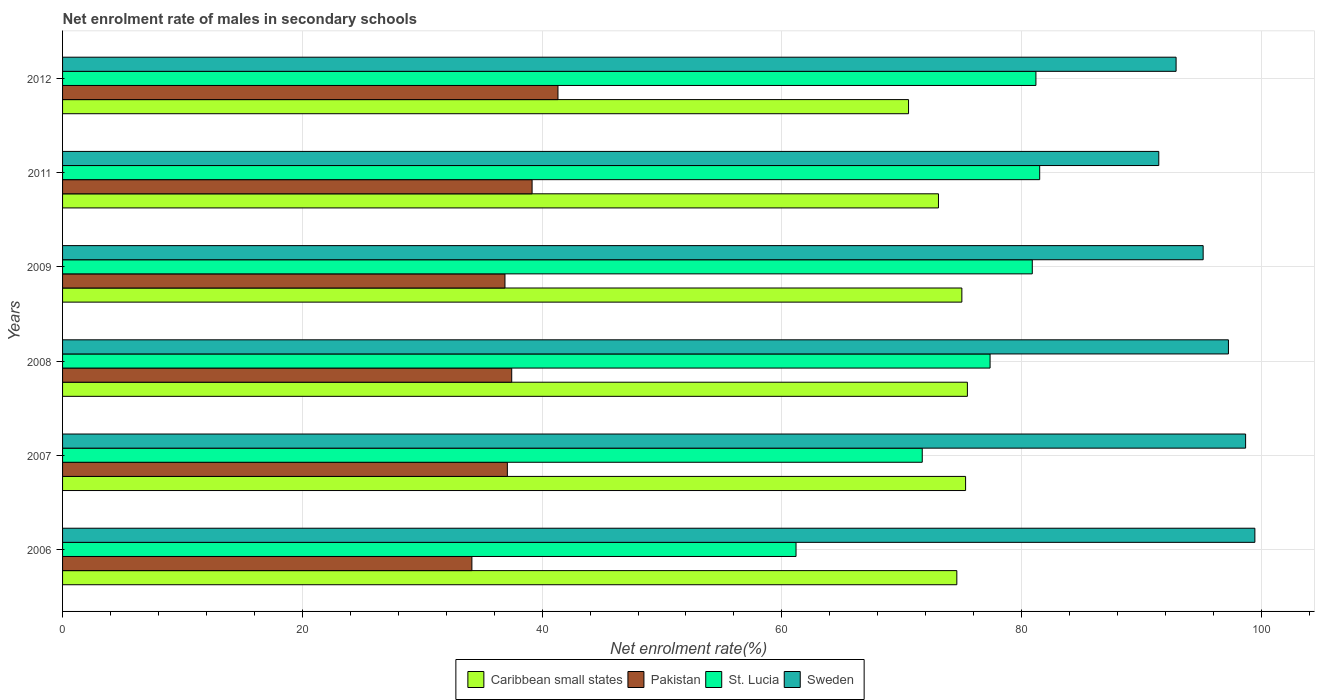How many groups of bars are there?
Keep it short and to the point. 6. How many bars are there on the 5th tick from the bottom?
Your answer should be compact. 4. What is the net enrolment rate of males in secondary schools in Sweden in 2007?
Your answer should be very brief. 98.68. Across all years, what is the maximum net enrolment rate of males in secondary schools in Caribbean small states?
Make the answer very short. 75.48. Across all years, what is the minimum net enrolment rate of males in secondary schools in Sweden?
Offer a terse response. 91.44. In which year was the net enrolment rate of males in secondary schools in Sweden maximum?
Provide a succinct answer. 2006. In which year was the net enrolment rate of males in secondary schools in Sweden minimum?
Offer a very short reply. 2011. What is the total net enrolment rate of males in secondary schools in Sweden in the graph?
Your answer should be very brief. 574.85. What is the difference between the net enrolment rate of males in secondary schools in Caribbean small states in 2008 and that in 2012?
Offer a terse response. 4.91. What is the difference between the net enrolment rate of males in secondary schools in Sweden in 2009 and the net enrolment rate of males in secondary schools in St. Lucia in 2011?
Offer a terse response. 13.63. What is the average net enrolment rate of males in secondary schools in Sweden per year?
Give a very brief answer. 95.81. In the year 2006, what is the difference between the net enrolment rate of males in secondary schools in St. Lucia and net enrolment rate of males in secondary schools in Sweden?
Offer a very short reply. -38.27. In how many years, is the net enrolment rate of males in secondary schools in Sweden greater than 24 %?
Make the answer very short. 6. What is the ratio of the net enrolment rate of males in secondary schools in St. Lucia in 2007 to that in 2008?
Your answer should be very brief. 0.93. Is the net enrolment rate of males in secondary schools in Pakistan in 2009 less than that in 2012?
Provide a short and direct response. Yes. What is the difference between the highest and the second highest net enrolment rate of males in secondary schools in Sweden?
Provide a succinct answer. 0.77. What is the difference between the highest and the lowest net enrolment rate of males in secondary schools in Caribbean small states?
Make the answer very short. 4.91. Is it the case that in every year, the sum of the net enrolment rate of males in secondary schools in Sweden and net enrolment rate of males in secondary schools in Caribbean small states is greater than the sum of net enrolment rate of males in secondary schools in Pakistan and net enrolment rate of males in secondary schools in St. Lucia?
Offer a very short reply. No. What does the 1st bar from the top in 2006 represents?
Your answer should be compact. Sweden. What does the 1st bar from the bottom in 2011 represents?
Keep it short and to the point. Caribbean small states. How many bars are there?
Provide a short and direct response. 24. What is the difference between two consecutive major ticks on the X-axis?
Keep it short and to the point. 20. Does the graph contain grids?
Ensure brevity in your answer.  Yes. Where does the legend appear in the graph?
Provide a short and direct response. Bottom center. How are the legend labels stacked?
Offer a terse response. Horizontal. What is the title of the graph?
Provide a short and direct response. Net enrolment rate of males in secondary schools. What is the label or title of the X-axis?
Make the answer very short. Net enrolment rate(%). What is the Net enrolment rate(%) in Caribbean small states in 2006?
Keep it short and to the point. 74.59. What is the Net enrolment rate(%) in Pakistan in 2006?
Offer a very short reply. 34.14. What is the Net enrolment rate(%) of St. Lucia in 2006?
Provide a succinct answer. 61.18. What is the Net enrolment rate(%) in Sweden in 2006?
Your answer should be compact. 99.46. What is the Net enrolment rate(%) in Caribbean small states in 2007?
Offer a very short reply. 75.32. What is the Net enrolment rate(%) of Pakistan in 2007?
Make the answer very short. 37.1. What is the Net enrolment rate(%) in St. Lucia in 2007?
Make the answer very short. 71.71. What is the Net enrolment rate(%) in Sweden in 2007?
Keep it short and to the point. 98.68. What is the Net enrolment rate(%) of Caribbean small states in 2008?
Make the answer very short. 75.48. What is the Net enrolment rate(%) in Pakistan in 2008?
Your response must be concise. 37.47. What is the Net enrolment rate(%) of St. Lucia in 2008?
Keep it short and to the point. 77.37. What is the Net enrolment rate(%) in Sweden in 2008?
Ensure brevity in your answer.  97.25. What is the Net enrolment rate(%) of Caribbean small states in 2009?
Your response must be concise. 75.01. What is the Net enrolment rate(%) in Pakistan in 2009?
Ensure brevity in your answer.  36.9. What is the Net enrolment rate(%) in St. Lucia in 2009?
Your response must be concise. 80.89. What is the Net enrolment rate(%) in Sweden in 2009?
Offer a terse response. 95.14. What is the Net enrolment rate(%) of Caribbean small states in 2011?
Your answer should be very brief. 73.06. What is the Net enrolment rate(%) of Pakistan in 2011?
Keep it short and to the point. 39.17. What is the Net enrolment rate(%) of St. Lucia in 2011?
Offer a terse response. 81.51. What is the Net enrolment rate(%) in Sweden in 2011?
Offer a terse response. 91.44. What is the Net enrolment rate(%) of Caribbean small states in 2012?
Your answer should be very brief. 70.57. What is the Net enrolment rate(%) of Pakistan in 2012?
Provide a short and direct response. 41.32. What is the Net enrolment rate(%) in St. Lucia in 2012?
Your response must be concise. 81.19. What is the Net enrolment rate(%) in Sweden in 2012?
Offer a very short reply. 92.88. Across all years, what is the maximum Net enrolment rate(%) of Caribbean small states?
Give a very brief answer. 75.48. Across all years, what is the maximum Net enrolment rate(%) in Pakistan?
Your answer should be compact. 41.32. Across all years, what is the maximum Net enrolment rate(%) of St. Lucia?
Your answer should be very brief. 81.51. Across all years, what is the maximum Net enrolment rate(%) in Sweden?
Offer a terse response. 99.46. Across all years, what is the minimum Net enrolment rate(%) of Caribbean small states?
Make the answer very short. 70.57. Across all years, what is the minimum Net enrolment rate(%) of Pakistan?
Your answer should be compact. 34.14. Across all years, what is the minimum Net enrolment rate(%) of St. Lucia?
Provide a short and direct response. 61.18. Across all years, what is the minimum Net enrolment rate(%) of Sweden?
Keep it short and to the point. 91.44. What is the total Net enrolment rate(%) of Caribbean small states in the graph?
Make the answer very short. 444.04. What is the total Net enrolment rate(%) in Pakistan in the graph?
Your response must be concise. 226.1. What is the total Net enrolment rate(%) in St. Lucia in the graph?
Provide a short and direct response. 453.84. What is the total Net enrolment rate(%) of Sweden in the graph?
Keep it short and to the point. 574.85. What is the difference between the Net enrolment rate(%) in Caribbean small states in 2006 and that in 2007?
Offer a very short reply. -0.73. What is the difference between the Net enrolment rate(%) in Pakistan in 2006 and that in 2007?
Your response must be concise. -2.96. What is the difference between the Net enrolment rate(%) in St. Lucia in 2006 and that in 2007?
Make the answer very short. -10.53. What is the difference between the Net enrolment rate(%) of Sweden in 2006 and that in 2007?
Offer a very short reply. 0.77. What is the difference between the Net enrolment rate(%) of Caribbean small states in 2006 and that in 2008?
Provide a short and direct response. -0.88. What is the difference between the Net enrolment rate(%) in Pakistan in 2006 and that in 2008?
Your answer should be very brief. -3.32. What is the difference between the Net enrolment rate(%) of St. Lucia in 2006 and that in 2008?
Offer a very short reply. -16.19. What is the difference between the Net enrolment rate(%) of Sweden in 2006 and that in 2008?
Offer a very short reply. 2.21. What is the difference between the Net enrolment rate(%) of Caribbean small states in 2006 and that in 2009?
Keep it short and to the point. -0.42. What is the difference between the Net enrolment rate(%) in Pakistan in 2006 and that in 2009?
Offer a very short reply. -2.76. What is the difference between the Net enrolment rate(%) in St. Lucia in 2006 and that in 2009?
Make the answer very short. -19.71. What is the difference between the Net enrolment rate(%) in Sweden in 2006 and that in 2009?
Keep it short and to the point. 4.31. What is the difference between the Net enrolment rate(%) in Caribbean small states in 2006 and that in 2011?
Provide a short and direct response. 1.53. What is the difference between the Net enrolment rate(%) in Pakistan in 2006 and that in 2011?
Your answer should be very brief. -5.02. What is the difference between the Net enrolment rate(%) of St. Lucia in 2006 and that in 2011?
Offer a terse response. -20.32. What is the difference between the Net enrolment rate(%) in Sweden in 2006 and that in 2011?
Keep it short and to the point. 8.02. What is the difference between the Net enrolment rate(%) in Caribbean small states in 2006 and that in 2012?
Make the answer very short. 4.03. What is the difference between the Net enrolment rate(%) in Pakistan in 2006 and that in 2012?
Make the answer very short. -7.18. What is the difference between the Net enrolment rate(%) in St. Lucia in 2006 and that in 2012?
Keep it short and to the point. -20.01. What is the difference between the Net enrolment rate(%) in Sweden in 2006 and that in 2012?
Ensure brevity in your answer.  6.57. What is the difference between the Net enrolment rate(%) of Caribbean small states in 2007 and that in 2008?
Ensure brevity in your answer.  -0.15. What is the difference between the Net enrolment rate(%) of Pakistan in 2007 and that in 2008?
Offer a very short reply. -0.36. What is the difference between the Net enrolment rate(%) of St. Lucia in 2007 and that in 2008?
Provide a short and direct response. -5.66. What is the difference between the Net enrolment rate(%) in Sweden in 2007 and that in 2008?
Ensure brevity in your answer.  1.43. What is the difference between the Net enrolment rate(%) of Caribbean small states in 2007 and that in 2009?
Offer a terse response. 0.31. What is the difference between the Net enrolment rate(%) of Pakistan in 2007 and that in 2009?
Give a very brief answer. 0.2. What is the difference between the Net enrolment rate(%) of St. Lucia in 2007 and that in 2009?
Ensure brevity in your answer.  -9.18. What is the difference between the Net enrolment rate(%) in Sweden in 2007 and that in 2009?
Provide a succinct answer. 3.54. What is the difference between the Net enrolment rate(%) in Caribbean small states in 2007 and that in 2011?
Your response must be concise. 2.26. What is the difference between the Net enrolment rate(%) of Pakistan in 2007 and that in 2011?
Provide a succinct answer. -2.06. What is the difference between the Net enrolment rate(%) in St. Lucia in 2007 and that in 2011?
Make the answer very short. -9.8. What is the difference between the Net enrolment rate(%) in Sweden in 2007 and that in 2011?
Offer a terse response. 7.24. What is the difference between the Net enrolment rate(%) of Caribbean small states in 2007 and that in 2012?
Make the answer very short. 4.76. What is the difference between the Net enrolment rate(%) in Pakistan in 2007 and that in 2012?
Your answer should be very brief. -4.22. What is the difference between the Net enrolment rate(%) of St. Lucia in 2007 and that in 2012?
Your answer should be very brief. -9.48. What is the difference between the Net enrolment rate(%) of Sweden in 2007 and that in 2012?
Offer a very short reply. 5.8. What is the difference between the Net enrolment rate(%) of Caribbean small states in 2008 and that in 2009?
Give a very brief answer. 0.46. What is the difference between the Net enrolment rate(%) of Pakistan in 2008 and that in 2009?
Your answer should be very brief. 0.56. What is the difference between the Net enrolment rate(%) in St. Lucia in 2008 and that in 2009?
Give a very brief answer. -3.52. What is the difference between the Net enrolment rate(%) of Sweden in 2008 and that in 2009?
Ensure brevity in your answer.  2.11. What is the difference between the Net enrolment rate(%) of Caribbean small states in 2008 and that in 2011?
Provide a short and direct response. 2.41. What is the difference between the Net enrolment rate(%) in Pakistan in 2008 and that in 2011?
Your answer should be compact. -1.7. What is the difference between the Net enrolment rate(%) of St. Lucia in 2008 and that in 2011?
Give a very brief answer. -4.14. What is the difference between the Net enrolment rate(%) in Sweden in 2008 and that in 2011?
Give a very brief answer. 5.81. What is the difference between the Net enrolment rate(%) of Caribbean small states in 2008 and that in 2012?
Your answer should be very brief. 4.91. What is the difference between the Net enrolment rate(%) in Pakistan in 2008 and that in 2012?
Your response must be concise. -3.86. What is the difference between the Net enrolment rate(%) in St. Lucia in 2008 and that in 2012?
Your response must be concise. -3.82. What is the difference between the Net enrolment rate(%) in Sweden in 2008 and that in 2012?
Keep it short and to the point. 4.37. What is the difference between the Net enrolment rate(%) of Caribbean small states in 2009 and that in 2011?
Offer a terse response. 1.95. What is the difference between the Net enrolment rate(%) of Pakistan in 2009 and that in 2011?
Your response must be concise. -2.26. What is the difference between the Net enrolment rate(%) of St. Lucia in 2009 and that in 2011?
Your answer should be compact. -0.62. What is the difference between the Net enrolment rate(%) in Sweden in 2009 and that in 2011?
Provide a succinct answer. 3.7. What is the difference between the Net enrolment rate(%) in Caribbean small states in 2009 and that in 2012?
Make the answer very short. 4.45. What is the difference between the Net enrolment rate(%) in Pakistan in 2009 and that in 2012?
Your response must be concise. -4.42. What is the difference between the Net enrolment rate(%) in St. Lucia in 2009 and that in 2012?
Provide a succinct answer. -0.3. What is the difference between the Net enrolment rate(%) in Sweden in 2009 and that in 2012?
Keep it short and to the point. 2.26. What is the difference between the Net enrolment rate(%) of Caribbean small states in 2011 and that in 2012?
Your answer should be compact. 2.5. What is the difference between the Net enrolment rate(%) in Pakistan in 2011 and that in 2012?
Offer a terse response. -2.16. What is the difference between the Net enrolment rate(%) in St. Lucia in 2011 and that in 2012?
Make the answer very short. 0.31. What is the difference between the Net enrolment rate(%) in Sweden in 2011 and that in 2012?
Your answer should be very brief. -1.44. What is the difference between the Net enrolment rate(%) of Caribbean small states in 2006 and the Net enrolment rate(%) of Pakistan in 2007?
Provide a short and direct response. 37.49. What is the difference between the Net enrolment rate(%) in Caribbean small states in 2006 and the Net enrolment rate(%) in St. Lucia in 2007?
Your response must be concise. 2.88. What is the difference between the Net enrolment rate(%) of Caribbean small states in 2006 and the Net enrolment rate(%) of Sweden in 2007?
Give a very brief answer. -24.09. What is the difference between the Net enrolment rate(%) in Pakistan in 2006 and the Net enrolment rate(%) in St. Lucia in 2007?
Give a very brief answer. -37.57. What is the difference between the Net enrolment rate(%) of Pakistan in 2006 and the Net enrolment rate(%) of Sweden in 2007?
Keep it short and to the point. -64.54. What is the difference between the Net enrolment rate(%) of St. Lucia in 2006 and the Net enrolment rate(%) of Sweden in 2007?
Keep it short and to the point. -37.5. What is the difference between the Net enrolment rate(%) of Caribbean small states in 2006 and the Net enrolment rate(%) of Pakistan in 2008?
Provide a short and direct response. 37.13. What is the difference between the Net enrolment rate(%) in Caribbean small states in 2006 and the Net enrolment rate(%) in St. Lucia in 2008?
Keep it short and to the point. -2.77. What is the difference between the Net enrolment rate(%) of Caribbean small states in 2006 and the Net enrolment rate(%) of Sweden in 2008?
Offer a terse response. -22.66. What is the difference between the Net enrolment rate(%) of Pakistan in 2006 and the Net enrolment rate(%) of St. Lucia in 2008?
Your answer should be very brief. -43.22. What is the difference between the Net enrolment rate(%) of Pakistan in 2006 and the Net enrolment rate(%) of Sweden in 2008?
Provide a succinct answer. -63.11. What is the difference between the Net enrolment rate(%) in St. Lucia in 2006 and the Net enrolment rate(%) in Sweden in 2008?
Provide a succinct answer. -36.07. What is the difference between the Net enrolment rate(%) of Caribbean small states in 2006 and the Net enrolment rate(%) of Pakistan in 2009?
Provide a short and direct response. 37.69. What is the difference between the Net enrolment rate(%) of Caribbean small states in 2006 and the Net enrolment rate(%) of St. Lucia in 2009?
Offer a very short reply. -6.29. What is the difference between the Net enrolment rate(%) of Caribbean small states in 2006 and the Net enrolment rate(%) of Sweden in 2009?
Your response must be concise. -20.55. What is the difference between the Net enrolment rate(%) in Pakistan in 2006 and the Net enrolment rate(%) in St. Lucia in 2009?
Offer a very short reply. -46.74. What is the difference between the Net enrolment rate(%) in Pakistan in 2006 and the Net enrolment rate(%) in Sweden in 2009?
Your response must be concise. -61. What is the difference between the Net enrolment rate(%) of St. Lucia in 2006 and the Net enrolment rate(%) of Sweden in 2009?
Your answer should be compact. -33.96. What is the difference between the Net enrolment rate(%) of Caribbean small states in 2006 and the Net enrolment rate(%) of Pakistan in 2011?
Your answer should be compact. 35.43. What is the difference between the Net enrolment rate(%) of Caribbean small states in 2006 and the Net enrolment rate(%) of St. Lucia in 2011?
Provide a short and direct response. -6.91. What is the difference between the Net enrolment rate(%) of Caribbean small states in 2006 and the Net enrolment rate(%) of Sweden in 2011?
Give a very brief answer. -16.85. What is the difference between the Net enrolment rate(%) of Pakistan in 2006 and the Net enrolment rate(%) of St. Lucia in 2011?
Your answer should be compact. -47.36. What is the difference between the Net enrolment rate(%) in Pakistan in 2006 and the Net enrolment rate(%) in Sweden in 2011?
Your answer should be compact. -57.3. What is the difference between the Net enrolment rate(%) of St. Lucia in 2006 and the Net enrolment rate(%) of Sweden in 2011?
Your answer should be very brief. -30.26. What is the difference between the Net enrolment rate(%) in Caribbean small states in 2006 and the Net enrolment rate(%) in Pakistan in 2012?
Make the answer very short. 33.27. What is the difference between the Net enrolment rate(%) of Caribbean small states in 2006 and the Net enrolment rate(%) of St. Lucia in 2012?
Your answer should be very brief. -6.6. What is the difference between the Net enrolment rate(%) in Caribbean small states in 2006 and the Net enrolment rate(%) in Sweden in 2012?
Offer a terse response. -18.29. What is the difference between the Net enrolment rate(%) in Pakistan in 2006 and the Net enrolment rate(%) in St. Lucia in 2012?
Provide a short and direct response. -47.05. What is the difference between the Net enrolment rate(%) in Pakistan in 2006 and the Net enrolment rate(%) in Sweden in 2012?
Provide a short and direct response. -58.74. What is the difference between the Net enrolment rate(%) in St. Lucia in 2006 and the Net enrolment rate(%) in Sweden in 2012?
Your answer should be very brief. -31.7. What is the difference between the Net enrolment rate(%) in Caribbean small states in 2007 and the Net enrolment rate(%) in Pakistan in 2008?
Your answer should be compact. 37.86. What is the difference between the Net enrolment rate(%) in Caribbean small states in 2007 and the Net enrolment rate(%) in St. Lucia in 2008?
Provide a succinct answer. -2.04. What is the difference between the Net enrolment rate(%) in Caribbean small states in 2007 and the Net enrolment rate(%) in Sweden in 2008?
Your answer should be very brief. -21.93. What is the difference between the Net enrolment rate(%) of Pakistan in 2007 and the Net enrolment rate(%) of St. Lucia in 2008?
Provide a succinct answer. -40.27. What is the difference between the Net enrolment rate(%) of Pakistan in 2007 and the Net enrolment rate(%) of Sweden in 2008?
Give a very brief answer. -60.15. What is the difference between the Net enrolment rate(%) in St. Lucia in 2007 and the Net enrolment rate(%) in Sweden in 2008?
Give a very brief answer. -25.54. What is the difference between the Net enrolment rate(%) in Caribbean small states in 2007 and the Net enrolment rate(%) in Pakistan in 2009?
Give a very brief answer. 38.42. What is the difference between the Net enrolment rate(%) in Caribbean small states in 2007 and the Net enrolment rate(%) in St. Lucia in 2009?
Offer a terse response. -5.56. What is the difference between the Net enrolment rate(%) in Caribbean small states in 2007 and the Net enrolment rate(%) in Sweden in 2009?
Your answer should be compact. -19.82. What is the difference between the Net enrolment rate(%) of Pakistan in 2007 and the Net enrolment rate(%) of St. Lucia in 2009?
Offer a terse response. -43.79. What is the difference between the Net enrolment rate(%) of Pakistan in 2007 and the Net enrolment rate(%) of Sweden in 2009?
Keep it short and to the point. -58.04. What is the difference between the Net enrolment rate(%) in St. Lucia in 2007 and the Net enrolment rate(%) in Sweden in 2009?
Give a very brief answer. -23.43. What is the difference between the Net enrolment rate(%) in Caribbean small states in 2007 and the Net enrolment rate(%) in Pakistan in 2011?
Provide a short and direct response. 36.16. What is the difference between the Net enrolment rate(%) of Caribbean small states in 2007 and the Net enrolment rate(%) of St. Lucia in 2011?
Your answer should be very brief. -6.18. What is the difference between the Net enrolment rate(%) in Caribbean small states in 2007 and the Net enrolment rate(%) in Sweden in 2011?
Provide a succinct answer. -16.11. What is the difference between the Net enrolment rate(%) of Pakistan in 2007 and the Net enrolment rate(%) of St. Lucia in 2011?
Your response must be concise. -44.4. What is the difference between the Net enrolment rate(%) in Pakistan in 2007 and the Net enrolment rate(%) in Sweden in 2011?
Offer a terse response. -54.34. What is the difference between the Net enrolment rate(%) in St. Lucia in 2007 and the Net enrolment rate(%) in Sweden in 2011?
Your answer should be compact. -19.73. What is the difference between the Net enrolment rate(%) of Caribbean small states in 2007 and the Net enrolment rate(%) of Pakistan in 2012?
Provide a short and direct response. 34. What is the difference between the Net enrolment rate(%) of Caribbean small states in 2007 and the Net enrolment rate(%) of St. Lucia in 2012?
Make the answer very short. -5.87. What is the difference between the Net enrolment rate(%) of Caribbean small states in 2007 and the Net enrolment rate(%) of Sweden in 2012?
Your answer should be very brief. -17.56. What is the difference between the Net enrolment rate(%) in Pakistan in 2007 and the Net enrolment rate(%) in St. Lucia in 2012?
Make the answer very short. -44.09. What is the difference between the Net enrolment rate(%) in Pakistan in 2007 and the Net enrolment rate(%) in Sweden in 2012?
Offer a very short reply. -55.78. What is the difference between the Net enrolment rate(%) in St. Lucia in 2007 and the Net enrolment rate(%) in Sweden in 2012?
Ensure brevity in your answer.  -21.17. What is the difference between the Net enrolment rate(%) in Caribbean small states in 2008 and the Net enrolment rate(%) in Pakistan in 2009?
Give a very brief answer. 38.57. What is the difference between the Net enrolment rate(%) of Caribbean small states in 2008 and the Net enrolment rate(%) of St. Lucia in 2009?
Make the answer very short. -5.41. What is the difference between the Net enrolment rate(%) in Caribbean small states in 2008 and the Net enrolment rate(%) in Sweden in 2009?
Keep it short and to the point. -19.67. What is the difference between the Net enrolment rate(%) of Pakistan in 2008 and the Net enrolment rate(%) of St. Lucia in 2009?
Your answer should be very brief. -43.42. What is the difference between the Net enrolment rate(%) in Pakistan in 2008 and the Net enrolment rate(%) in Sweden in 2009?
Make the answer very short. -57.68. What is the difference between the Net enrolment rate(%) in St. Lucia in 2008 and the Net enrolment rate(%) in Sweden in 2009?
Give a very brief answer. -17.77. What is the difference between the Net enrolment rate(%) in Caribbean small states in 2008 and the Net enrolment rate(%) in Pakistan in 2011?
Your response must be concise. 36.31. What is the difference between the Net enrolment rate(%) in Caribbean small states in 2008 and the Net enrolment rate(%) in St. Lucia in 2011?
Your answer should be compact. -6.03. What is the difference between the Net enrolment rate(%) of Caribbean small states in 2008 and the Net enrolment rate(%) of Sweden in 2011?
Provide a succinct answer. -15.96. What is the difference between the Net enrolment rate(%) of Pakistan in 2008 and the Net enrolment rate(%) of St. Lucia in 2011?
Offer a terse response. -44.04. What is the difference between the Net enrolment rate(%) in Pakistan in 2008 and the Net enrolment rate(%) in Sweden in 2011?
Offer a very short reply. -53.97. What is the difference between the Net enrolment rate(%) of St. Lucia in 2008 and the Net enrolment rate(%) of Sweden in 2011?
Offer a terse response. -14.07. What is the difference between the Net enrolment rate(%) of Caribbean small states in 2008 and the Net enrolment rate(%) of Pakistan in 2012?
Ensure brevity in your answer.  34.15. What is the difference between the Net enrolment rate(%) in Caribbean small states in 2008 and the Net enrolment rate(%) in St. Lucia in 2012?
Give a very brief answer. -5.72. What is the difference between the Net enrolment rate(%) in Caribbean small states in 2008 and the Net enrolment rate(%) in Sweden in 2012?
Provide a short and direct response. -17.41. What is the difference between the Net enrolment rate(%) of Pakistan in 2008 and the Net enrolment rate(%) of St. Lucia in 2012?
Offer a very short reply. -43.73. What is the difference between the Net enrolment rate(%) of Pakistan in 2008 and the Net enrolment rate(%) of Sweden in 2012?
Offer a terse response. -55.42. What is the difference between the Net enrolment rate(%) of St. Lucia in 2008 and the Net enrolment rate(%) of Sweden in 2012?
Your answer should be compact. -15.52. What is the difference between the Net enrolment rate(%) of Caribbean small states in 2009 and the Net enrolment rate(%) of Pakistan in 2011?
Offer a very short reply. 35.85. What is the difference between the Net enrolment rate(%) of Caribbean small states in 2009 and the Net enrolment rate(%) of St. Lucia in 2011?
Make the answer very short. -6.49. What is the difference between the Net enrolment rate(%) of Caribbean small states in 2009 and the Net enrolment rate(%) of Sweden in 2011?
Ensure brevity in your answer.  -16.43. What is the difference between the Net enrolment rate(%) of Pakistan in 2009 and the Net enrolment rate(%) of St. Lucia in 2011?
Give a very brief answer. -44.6. What is the difference between the Net enrolment rate(%) of Pakistan in 2009 and the Net enrolment rate(%) of Sweden in 2011?
Provide a succinct answer. -54.54. What is the difference between the Net enrolment rate(%) in St. Lucia in 2009 and the Net enrolment rate(%) in Sweden in 2011?
Your answer should be very brief. -10.55. What is the difference between the Net enrolment rate(%) of Caribbean small states in 2009 and the Net enrolment rate(%) of Pakistan in 2012?
Provide a short and direct response. 33.69. What is the difference between the Net enrolment rate(%) of Caribbean small states in 2009 and the Net enrolment rate(%) of St. Lucia in 2012?
Make the answer very short. -6.18. What is the difference between the Net enrolment rate(%) in Caribbean small states in 2009 and the Net enrolment rate(%) in Sweden in 2012?
Ensure brevity in your answer.  -17.87. What is the difference between the Net enrolment rate(%) of Pakistan in 2009 and the Net enrolment rate(%) of St. Lucia in 2012?
Provide a short and direct response. -44.29. What is the difference between the Net enrolment rate(%) in Pakistan in 2009 and the Net enrolment rate(%) in Sweden in 2012?
Your answer should be very brief. -55.98. What is the difference between the Net enrolment rate(%) of St. Lucia in 2009 and the Net enrolment rate(%) of Sweden in 2012?
Provide a succinct answer. -12. What is the difference between the Net enrolment rate(%) of Caribbean small states in 2011 and the Net enrolment rate(%) of Pakistan in 2012?
Your answer should be very brief. 31.74. What is the difference between the Net enrolment rate(%) in Caribbean small states in 2011 and the Net enrolment rate(%) in St. Lucia in 2012?
Ensure brevity in your answer.  -8.13. What is the difference between the Net enrolment rate(%) in Caribbean small states in 2011 and the Net enrolment rate(%) in Sweden in 2012?
Make the answer very short. -19.82. What is the difference between the Net enrolment rate(%) of Pakistan in 2011 and the Net enrolment rate(%) of St. Lucia in 2012?
Offer a very short reply. -42.03. What is the difference between the Net enrolment rate(%) in Pakistan in 2011 and the Net enrolment rate(%) in Sweden in 2012?
Offer a very short reply. -53.72. What is the difference between the Net enrolment rate(%) of St. Lucia in 2011 and the Net enrolment rate(%) of Sweden in 2012?
Keep it short and to the point. -11.38. What is the average Net enrolment rate(%) in Caribbean small states per year?
Provide a succinct answer. 74.01. What is the average Net enrolment rate(%) of Pakistan per year?
Provide a short and direct response. 37.68. What is the average Net enrolment rate(%) of St. Lucia per year?
Your response must be concise. 75.64. What is the average Net enrolment rate(%) of Sweden per year?
Your answer should be very brief. 95.81. In the year 2006, what is the difference between the Net enrolment rate(%) in Caribbean small states and Net enrolment rate(%) in Pakistan?
Make the answer very short. 40.45. In the year 2006, what is the difference between the Net enrolment rate(%) of Caribbean small states and Net enrolment rate(%) of St. Lucia?
Give a very brief answer. 13.41. In the year 2006, what is the difference between the Net enrolment rate(%) in Caribbean small states and Net enrolment rate(%) in Sweden?
Your answer should be very brief. -24.86. In the year 2006, what is the difference between the Net enrolment rate(%) of Pakistan and Net enrolment rate(%) of St. Lucia?
Offer a terse response. -27.04. In the year 2006, what is the difference between the Net enrolment rate(%) of Pakistan and Net enrolment rate(%) of Sweden?
Ensure brevity in your answer.  -65.31. In the year 2006, what is the difference between the Net enrolment rate(%) in St. Lucia and Net enrolment rate(%) in Sweden?
Make the answer very short. -38.27. In the year 2007, what is the difference between the Net enrolment rate(%) in Caribbean small states and Net enrolment rate(%) in Pakistan?
Your response must be concise. 38.22. In the year 2007, what is the difference between the Net enrolment rate(%) in Caribbean small states and Net enrolment rate(%) in St. Lucia?
Provide a succinct answer. 3.61. In the year 2007, what is the difference between the Net enrolment rate(%) in Caribbean small states and Net enrolment rate(%) in Sweden?
Your response must be concise. -23.36. In the year 2007, what is the difference between the Net enrolment rate(%) in Pakistan and Net enrolment rate(%) in St. Lucia?
Offer a very short reply. -34.61. In the year 2007, what is the difference between the Net enrolment rate(%) in Pakistan and Net enrolment rate(%) in Sweden?
Keep it short and to the point. -61.58. In the year 2007, what is the difference between the Net enrolment rate(%) of St. Lucia and Net enrolment rate(%) of Sweden?
Ensure brevity in your answer.  -26.97. In the year 2008, what is the difference between the Net enrolment rate(%) of Caribbean small states and Net enrolment rate(%) of Pakistan?
Give a very brief answer. 38.01. In the year 2008, what is the difference between the Net enrolment rate(%) in Caribbean small states and Net enrolment rate(%) in St. Lucia?
Keep it short and to the point. -1.89. In the year 2008, what is the difference between the Net enrolment rate(%) in Caribbean small states and Net enrolment rate(%) in Sweden?
Your answer should be compact. -21.77. In the year 2008, what is the difference between the Net enrolment rate(%) of Pakistan and Net enrolment rate(%) of St. Lucia?
Your answer should be compact. -39.9. In the year 2008, what is the difference between the Net enrolment rate(%) in Pakistan and Net enrolment rate(%) in Sweden?
Your response must be concise. -59.78. In the year 2008, what is the difference between the Net enrolment rate(%) of St. Lucia and Net enrolment rate(%) of Sweden?
Your response must be concise. -19.88. In the year 2009, what is the difference between the Net enrolment rate(%) in Caribbean small states and Net enrolment rate(%) in Pakistan?
Your answer should be compact. 38.11. In the year 2009, what is the difference between the Net enrolment rate(%) in Caribbean small states and Net enrolment rate(%) in St. Lucia?
Provide a succinct answer. -5.87. In the year 2009, what is the difference between the Net enrolment rate(%) in Caribbean small states and Net enrolment rate(%) in Sweden?
Offer a terse response. -20.13. In the year 2009, what is the difference between the Net enrolment rate(%) of Pakistan and Net enrolment rate(%) of St. Lucia?
Your answer should be compact. -43.98. In the year 2009, what is the difference between the Net enrolment rate(%) of Pakistan and Net enrolment rate(%) of Sweden?
Offer a terse response. -58.24. In the year 2009, what is the difference between the Net enrolment rate(%) of St. Lucia and Net enrolment rate(%) of Sweden?
Your answer should be very brief. -14.25. In the year 2011, what is the difference between the Net enrolment rate(%) of Caribbean small states and Net enrolment rate(%) of Pakistan?
Ensure brevity in your answer.  33.9. In the year 2011, what is the difference between the Net enrolment rate(%) in Caribbean small states and Net enrolment rate(%) in St. Lucia?
Give a very brief answer. -8.44. In the year 2011, what is the difference between the Net enrolment rate(%) in Caribbean small states and Net enrolment rate(%) in Sweden?
Provide a short and direct response. -18.38. In the year 2011, what is the difference between the Net enrolment rate(%) in Pakistan and Net enrolment rate(%) in St. Lucia?
Make the answer very short. -42.34. In the year 2011, what is the difference between the Net enrolment rate(%) in Pakistan and Net enrolment rate(%) in Sweden?
Your answer should be very brief. -52.27. In the year 2011, what is the difference between the Net enrolment rate(%) of St. Lucia and Net enrolment rate(%) of Sweden?
Offer a terse response. -9.93. In the year 2012, what is the difference between the Net enrolment rate(%) of Caribbean small states and Net enrolment rate(%) of Pakistan?
Keep it short and to the point. 29.24. In the year 2012, what is the difference between the Net enrolment rate(%) in Caribbean small states and Net enrolment rate(%) in St. Lucia?
Give a very brief answer. -10.62. In the year 2012, what is the difference between the Net enrolment rate(%) in Caribbean small states and Net enrolment rate(%) in Sweden?
Ensure brevity in your answer.  -22.32. In the year 2012, what is the difference between the Net enrolment rate(%) of Pakistan and Net enrolment rate(%) of St. Lucia?
Your response must be concise. -39.87. In the year 2012, what is the difference between the Net enrolment rate(%) of Pakistan and Net enrolment rate(%) of Sweden?
Your answer should be very brief. -51.56. In the year 2012, what is the difference between the Net enrolment rate(%) of St. Lucia and Net enrolment rate(%) of Sweden?
Make the answer very short. -11.69. What is the ratio of the Net enrolment rate(%) of Caribbean small states in 2006 to that in 2007?
Provide a short and direct response. 0.99. What is the ratio of the Net enrolment rate(%) in Pakistan in 2006 to that in 2007?
Your answer should be very brief. 0.92. What is the ratio of the Net enrolment rate(%) of St. Lucia in 2006 to that in 2007?
Make the answer very short. 0.85. What is the ratio of the Net enrolment rate(%) in Sweden in 2006 to that in 2007?
Your answer should be compact. 1.01. What is the ratio of the Net enrolment rate(%) in Caribbean small states in 2006 to that in 2008?
Provide a short and direct response. 0.99. What is the ratio of the Net enrolment rate(%) of Pakistan in 2006 to that in 2008?
Provide a short and direct response. 0.91. What is the ratio of the Net enrolment rate(%) in St. Lucia in 2006 to that in 2008?
Provide a succinct answer. 0.79. What is the ratio of the Net enrolment rate(%) in Sweden in 2006 to that in 2008?
Offer a very short reply. 1.02. What is the ratio of the Net enrolment rate(%) of Pakistan in 2006 to that in 2009?
Provide a succinct answer. 0.93. What is the ratio of the Net enrolment rate(%) of St. Lucia in 2006 to that in 2009?
Make the answer very short. 0.76. What is the ratio of the Net enrolment rate(%) of Sweden in 2006 to that in 2009?
Offer a terse response. 1.05. What is the ratio of the Net enrolment rate(%) in Pakistan in 2006 to that in 2011?
Make the answer very short. 0.87. What is the ratio of the Net enrolment rate(%) of St. Lucia in 2006 to that in 2011?
Your answer should be very brief. 0.75. What is the ratio of the Net enrolment rate(%) in Sweden in 2006 to that in 2011?
Your response must be concise. 1.09. What is the ratio of the Net enrolment rate(%) of Caribbean small states in 2006 to that in 2012?
Provide a succinct answer. 1.06. What is the ratio of the Net enrolment rate(%) in Pakistan in 2006 to that in 2012?
Provide a short and direct response. 0.83. What is the ratio of the Net enrolment rate(%) in St. Lucia in 2006 to that in 2012?
Ensure brevity in your answer.  0.75. What is the ratio of the Net enrolment rate(%) in Sweden in 2006 to that in 2012?
Give a very brief answer. 1.07. What is the ratio of the Net enrolment rate(%) of Caribbean small states in 2007 to that in 2008?
Offer a terse response. 1. What is the ratio of the Net enrolment rate(%) in Pakistan in 2007 to that in 2008?
Keep it short and to the point. 0.99. What is the ratio of the Net enrolment rate(%) of St. Lucia in 2007 to that in 2008?
Make the answer very short. 0.93. What is the ratio of the Net enrolment rate(%) of Sweden in 2007 to that in 2008?
Make the answer very short. 1.01. What is the ratio of the Net enrolment rate(%) in Pakistan in 2007 to that in 2009?
Make the answer very short. 1.01. What is the ratio of the Net enrolment rate(%) of St. Lucia in 2007 to that in 2009?
Your answer should be compact. 0.89. What is the ratio of the Net enrolment rate(%) in Sweden in 2007 to that in 2009?
Your response must be concise. 1.04. What is the ratio of the Net enrolment rate(%) in Caribbean small states in 2007 to that in 2011?
Your answer should be compact. 1.03. What is the ratio of the Net enrolment rate(%) in Pakistan in 2007 to that in 2011?
Give a very brief answer. 0.95. What is the ratio of the Net enrolment rate(%) in St. Lucia in 2007 to that in 2011?
Offer a very short reply. 0.88. What is the ratio of the Net enrolment rate(%) of Sweden in 2007 to that in 2011?
Ensure brevity in your answer.  1.08. What is the ratio of the Net enrolment rate(%) of Caribbean small states in 2007 to that in 2012?
Your response must be concise. 1.07. What is the ratio of the Net enrolment rate(%) in Pakistan in 2007 to that in 2012?
Provide a short and direct response. 0.9. What is the ratio of the Net enrolment rate(%) of St. Lucia in 2007 to that in 2012?
Your answer should be compact. 0.88. What is the ratio of the Net enrolment rate(%) in Sweden in 2007 to that in 2012?
Your answer should be very brief. 1.06. What is the ratio of the Net enrolment rate(%) of Caribbean small states in 2008 to that in 2009?
Provide a short and direct response. 1.01. What is the ratio of the Net enrolment rate(%) of Pakistan in 2008 to that in 2009?
Your answer should be very brief. 1.02. What is the ratio of the Net enrolment rate(%) in St. Lucia in 2008 to that in 2009?
Offer a terse response. 0.96. What is the ratio of the Net enrolment rate(%) in Sweden in 2008 to that in 2009?
Offer a terse response. 1.02. What is the ratio of the Net enrolment rate(%) in Caribbean small states in 2008 to that in 2011?
Offer a very short reply. 1.03. What is the ratio of the Net enrolment rate(%) of Pakistan in 2008 to that in 2011?
Give a very brief answer. 0.96. What is the ratio of the Net enrolment rate(%) in St. Lucia in 2008 to that in 2011?
Provide a succinct answer. 0.95. What is the ratio of the Net enrolment rate(%) in Sweden in 2008 to that in 2011?
Provide a short and direct response. 1.06. What is the ratio of the Net enrolment rate(%) in Caribbean small states in 2008 to that in 2012?
Provide a succinct answer. 1.07. What is the ratio of the Net enrolment rate(%) in Pakistan in 2008 to that in 2012?
Make the answer very short. 0.91. What is the ratio of the Net enrolment rate(%) in St. Lucia in 2008 to that in 2012?
Your answer should be very brief. 0.95. What is the ratio of the Net enrolment rate(%) in Sweden in 2008 to that in 2012?
Offer a very short reply. 1.05. What is the ratio of the Net enrolment rate(%) in Caribbean small states in 2009 to that in 2011?
Keep it short and to the point. 1.03. What is the ratio of the Net enrolment rate(%) in Pakistan in 2009 to that in 2011?
Provide a short and direct response. 0.94. What is the ratio of the Net enrolment rate(%) of St. Lucia in 2009 to that in 2011?
Provide a succinct answer. 0.99. What is the ratio of the Net enrolment rate(%) in Sweden in 2009 to that in 2011?
Provide a succinct answer. 1.04. What is the ratio of the Net enrolment rate(%) in Caribbean small states in 2009 to that in 2012?
Provide a short and direct response. 1.06. What is the ratio of the Net enrolment rate(%) of Pakistan in 2009 to that in 2012?
Provide a succinct answer. 0.89. What is the ratio of the Net enrolment rate(%) in Sweden in 2009 to that in 2012?
Keep it short and to the point. 1.02. What is the ratio of the Net enrolment rate(%) in Caribbean small states in 2011 to that in 2012?
Your response must be concise. 1.04. What is the ratio of the Net enrolment rate(%) in Pakistan in 2011 to that in 2012?
Your answer should be compact. 0.95. What is the ratio of the Net enrolment rate(%) of Sweden in 2011 to that in 2012?
Your answer should be compact. 0.98. What is the difference between the highest and the second highest Net enrolment rate(%) of Caribbean small states?
Your answer should be compact. 0.15. What is the difference between the highest and the second highest Net enrolment rate(%) in Pakistan?
Keep it short and to the point. 2.16. What is the difference between the highest and the second highest Net enrolment rate(%) of St. Lucia?
Make the answer very short. 0.31. What is the difference between the highest and the second highest Net enrolment rate(%) in Sweden?
Your answer should be compact. 0.77. What is the difference between the highest and the lowest Net enrolment rate(%) of Caribbean small states?
Provide a succinct answer. 4.91. What is the difference between the highest and the lowest Net enrolment rate(%) of Pakistan?
Offer a very short reply. 7.18. What is the difference between the highest and the lowest Net enrolment rate(%) in St. Lucia?
Your answer should be very brief. 20.32. What is the difference between the highest and the lowest Net enrolment rate(%) in Sweden?
Offer a terse response. 8.02. 